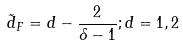<formula> <loc_0><loc_0><loc_500><loc_500>\tilde { d } _ { F } = d - \frac { 2 } { \delta - 1 } ; d = 1 , 2</formula> 